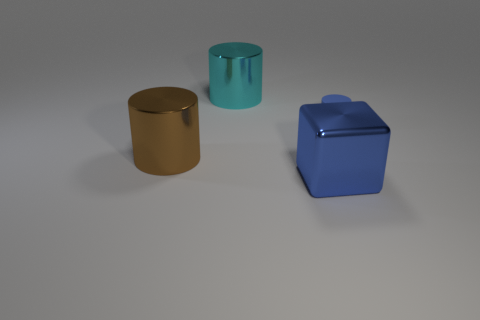Subtract all large metallic cylinders. How many cylinders are left? 1 Subtract all cylinders. How many objects are left? 1 Add 1 large red matte cylinders. How many objects exist? 5 Subtract all blue cylinders. How many cylinders are left? 2 Subtract 2 cylinders. How many cylinders are left? 1 Subtract all purple cylinders. Subtract all red balls. How many cylinders are left? 3 Subtract all gray cubes. How many green cylinders are left? 0 Subtract all brown metallic cylinders. Subtract all blue matte objects. How many objects are left? 2 Add 3 big metal objects. How many big metal objects are left? 6 Add 2 large brown things. How many large brown things exist? 3 